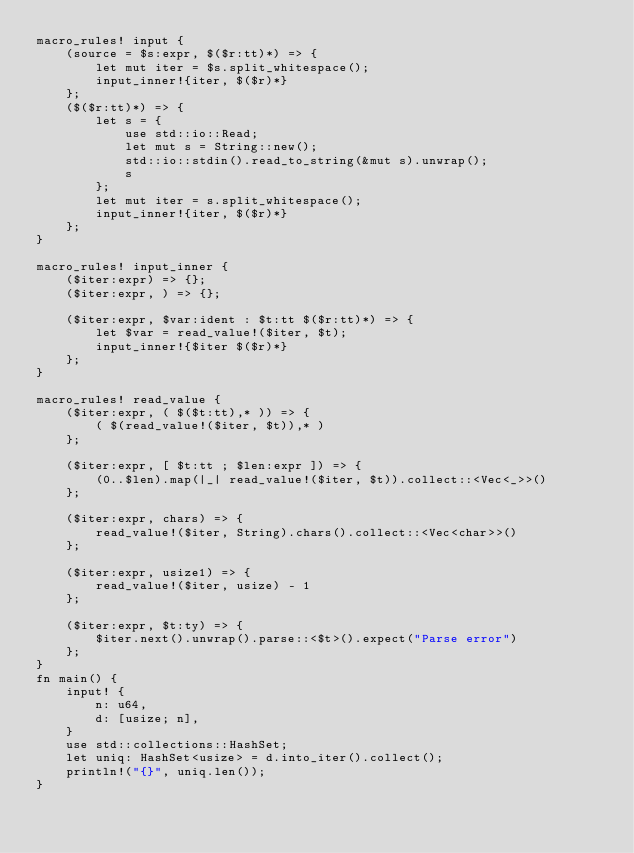Convert code to text. <code><loc_0><loc_0><loc_500><loc_500><_Rust_>macro_rules! input {
    (source = $s:expr, $($r:tt)*) => {
        let mut iter = $s.split_whitespace();
        input_inner!{iter, $($r)*}
    };
    ($($r:tt)*) => {
        let s = {
            use std::io::Read;
            let mut s = String::new();
            std::io::stdin().read_to_string(&mut s).unwrap();
            s
        };
        let mut iter = s.split_whitespace();
        input_inner!{iter, $($r)*}
    };
}

macro_rules! input_inner {
    ($iter:expr) => {};
    ($iter:expr, ) => {};

    ($iter:expr, $var:ident : $t:tt $($r:tt)*) => {
        let $var = read_value!($iter, $t);
        input_inner!{$iter $($r)*}
    };
}

macro_rules! read_value {
    ($iter:expr, ( $($t:tt),* )) => {
        ( $(read_value!($iter, $t)),* )
    };

    ($iter:expr, [ $t:tt ; $len:expr ]) => {
        (0..$len).map(|_| read_value!($iter, $t)).collect::<Vec<_>>()
    };

    ($iter:expr, chars) => {
        read_value!($iter, String).chars().collect::<Vec<char>>()
    };

    ($iter:expr, usize1) => {
        read_value!($iter, usize) - 1
    };

    ($iter:expr, $t:ty) => {
        $iter.next().unwrap().parse::<$t>().expect("Parse error")
    };
}
fn main() {
    input! {
        n: u64,
        d: [usize; n],
    }
    use std::collections::HashSet;
    let uniq: HashSet<usize> = d.into_iter().collect();
    println!("{}", uniq.len());
}
 </code> 